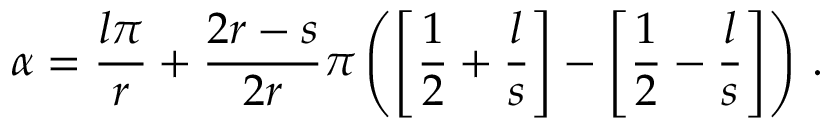<formula> <loc_0><loc_0><loc_500><loc_500>\alpha = \frac { l \pi } { r } + \frac { 2 r - s } { 2 r } \pi \left ( \left [ \frac { 1 } { 2 } + \frac { l } { s } \right ] - \left [ \frac { 1 } { 2 } - \frac { l } { s } \right ] \right ) \, .</formula> 